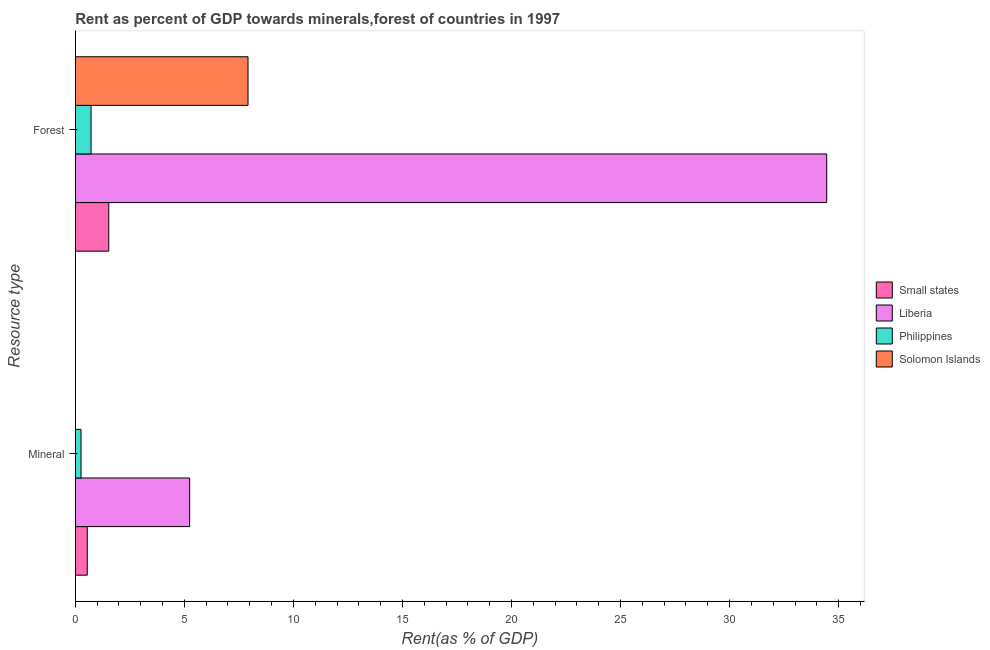How many different coloured bars are there?
Your answer should be very brief. 4. How many groups of bars are there?
Provide a succinct answer. 2. Are the number of bars on each tick of the Y-axis equal?
Provide a short and direct response. Yes. How many bars are there on the 2nd tick from the top?
Give a very brief answer. 4. How many bars are there on the 1st tick from the bottom?
Keep it short and to the point. 4. What is the label of the 2nd group of bars from the top?
Offer a terse response. Mineral. What is the forest rent in Solomon Islands?
Offer a terse response. 7.92. Across all countries, what is the maximum forest rent?
Offer a very short reply. 34.45. Across all countries, what is the minimum mineral rent?
Your answer should be very brief. 0. In which country was the mineral rent maximum?
Keep it short and to the point. Liberia. In which country was the forest rent minimum?
Provide a succinct answer. Philippines. What is the total forest rent in the graph?
Give a very brief answer. 44.63. What is the difference between the forest rent in Liberia and that in Solomon Islands?
Ensure brevity in your answer.  26.53. What is the difference between the mineral rent in Solomon Islands and the forest rent in Small states?
Offer a very short reply. -1.53. What is the average mineral rent per country?
Your answer should be compact. 1.51. What is the difference between the forest rent and mineral rent in Philippines?
Give a very brief answer. 0.46. In how many countries, is the forest rent greater than 20 %?
Give a very brief answer. 1. What is the ratio of the forest rent in Small states to that in Liberia?
Give a very brief answer. 0.04. Is the mineral rent in Small states less than that in Solomon Islands?
Your answer should be compact. No. What does the 4th bar from the top in Mineral represents?
Your answer should be compact. Small states. What does the 4th bar from the bottom in Mineral represents?
Offer a terse response. Solomon Islands. How many bars are there?
Provide a short and direct response. 8. How many countries are there in the graph?
Ensure brevity in your answer.  4. Does the graph contain grids?
Your response must be concise. No. What is the title of the graph?
Offer a terse response. Rent as percent of GDP towards minerals,forest of countries in 1997. What is the label or title of the X-axis?
Your answer should be very brief. Rent(as % of GDP). What is the label or title of the Y-axis?
Your answer should be very brief. Resource type. What is the Rent(as % of GDP) of Small states in Mineral?
Your response must be concise. 0.55. What is the Rent(as % of GDP) in Liberia in Mineral?
Offer a terse response. 5.24. What is the Rent(as % of GDP) in Philippines in Mineral?
Provide a short and direct response. 0.26. What is the Rent(as % of GDP) in Solomon Islands in Mineral?
Your answer should be compact. 0. What is the Rent(as % of GDP) of Small states in Forest?
Your response must be concise. 1.53. What is the Rent(as % of GDP) in Liberia in Forest?
Keep it short and to the point. 34.45. What is the Rent(as % of GDP) in Philippines in Forest?
Your answer should be compact. 0.72. What is the Rent(as % of GDP) in Solomon Islands in Forest?
Your response must be concise. 7.92. Across all Resource type, what is the maximum Rent(as % of GDP) in Small states?
Make the answer very short. 1.53. Across all Resource type, what is the maximum Rent(as % of GDP) of Liberia?
Keep it short and to the point. 34.45. Across all Resource type, what is the maximum Rent(as % of GDP) of Philippines?
Your response must be concise. 0.72. Across all Resource type, what is the maximum Rent(as % of GDP) in Solomon Islands?
Your answer should be compact. 7.92. Across all Resource type, what is the minimum Rent(as % of GDP) in Small states?
Your answer should be very brief. 0.55. Across all Resource type, what is the minimum Rent(as % of GDP) in Liberia?
Offer a terse response. 5.24. Across all Resource type, what is the minimum Rent(as % of GDP) of Philippines?
Provide a succinct answer. 0.26. Across all Resource type, what is the minimum Rent(as % of GDP) of Solomon Islands?
Offer a terse response. 0. What is the total Rent(as % of GDP) of Small states in the graph?
Offer a terse response. 2.08. What is the total Rent(as % of GDP) in Liberia in the graph?
Keep it short and to the point. 39.69. What is the total Rent(as % of GDP) in Philippines in the graph?
Your response must be concise. 0.98. What is the total Rent(as % of GDP) in Solomon Islands in the graph?
Your response must be concise. 7.92. What is the difference between the Rent(as % of GDP) in Small states in Mineral and that in Forest?
Your answer should be very brief. -0.98. What is the difference between the Rent(as % of GDP) of Liberia in Mineral and that in Forest?
Provide a succinct answer. -29.21. What is the difference between the Rent(as % of GDP) of Philippines in Mineral and that in Forest?
Offer a terse response. -0.46. What is the difference between the Rent(as % of GDP) of Solomon Islands in Mineral and that in Forest?
Keep it short and to the point. -7.92. What is the difference between the Rent(as % of GDP) in Small states in Mineral and the Rent(as % of GDP) in Liberia in Forest?
Offer a terse response. -33.9. What is the difference between the Rent(as % of GDP) of Small states in Mineral and the Rent(as % of GDP) of Philippines in Forest?
Offer a very short reply. -0.17. What is the difference between the Rent(as % of GDP) in Small states in Mineral and the Rent(as % of GDP) in Solomon Islands in Forest?
Give a very brief answer. -7.37. What is the difference between the Rent(as % of GDP) of Liberia in Mineral and the Rent(as % of GDP) of Philippines in Forest?
Offer a very short reply. 4.52. What is the difference between the Rent(as % of GDP) of Liberia in Mineral and the Rent(as % of GDP) of Solomon Islands in Forest?
Offer a very short reply. -2.68. What is the difference between the Rent(as % of GDP) of Philippines in Mineral and the Rent(as % of GDP) of Solomon Islands in Forest?
Offer a very short reply. -7.66. What is the average Rent(as % of GDP) in Small states per Resource type?
Your answer should be compact. 1.04. What is the average Rent(as % of GDP) of Liberia per Resource type?
Provide a succinct answer. 19.85. What is the average Rent(as % of GDP) in Philippines per Resource type?
Give a very brief answer. 0.49. What is the average Rent(as % of GDP) of Solomon Islands per Resource type?
Provide a succinct answer. 3.96. What is the difference between the Rent(as % of GDP) of Small states and Rent(as % of GDP) of Liberia in Mineral?
Ensure brevity in your answer.  -4.69. What is the difference between the Rent(as % of GDP) in Small states and Rent(as % of GDP) in Philippines in Mineral?
Ensure brevity in your answer.  0.29. What is the difference between the Rent(as % of GDP) in Small states and Rent(as % of GDP) in Solomon Islands in Mineral?
Offer a terse response. 0.55. What is the difference between the Rent(as % of GDP) of Liberia and Rent(as % of GDP) of Philippines in Mineral?
Offer a terse response. 4.98. What is the difference between the Rent(as % of GDP) of Liberia and Rent(as % of GDP) of Solomon Islands in Mineral?
Make the answer very short. 5.24. What is the difference between the Rent(as % of GDP) in Philippines and Rent(as % of GDP) in Solomon Islands in Mineral?
Offer a terse response. 0.26. What is the difference between the Rent(as % of GDP) of Small states and Rent(as % of GDP) of Liberia in Forest?
Keep it short and to the point. -32.92. What is the difference between the Rent(as % of GDP) in Small states and Rent(as % of GDP) in Philippines in Forest?
Offer a terse response. 0.81. What is the difference between the Rent(as % of GDP) in Small states and Rent(as % of GDP) in Solomon Islands in Forest?
Offer a very short reply. -6.39. What is the difference between the Rent(as % of GDP) in Liberia and Rent(as % of GDP) in Philippines in Forest?
Your answer should be very brief. 33.73. What is the difference between the Rent(as % of GDP) of Liberia and Rent(as % of GDP) of Solomon Islands in Forest?
Your answer should be very brief. 26.53. What is the difference between the Rent(as % of GDP) in Philippines and Rent(as % of GDP) in Solomon Islands in Forest?
Keep it short and to the point. -7.2. What is the ratio of the Rent(as % of GDP) in Small states in Mineral to that in Forest?
Your answer should be compact. 0.36. What is the ratio of the Rent(as % of GDP) of Liberia in Mineral to that in Forest?
Give a very brief answer. 0.15. What is the ratio of the Rent(as % of GDP) of Philippines in Mineral to that in Forest?
Your answer should be very brief. 0.36. What is the ratio of the Rent(as % of GDP) in Solomon Islands in Mineral to that in Forest?
Your answer should be compact. 0. What is the difference between the highest and the second highest Rent(as % of GDP) in Small states?
Ensure brevity in your answer.  0.98. What is the difference between the highest and the second highest Rent(as % of GDP) of Liberia?
Provide a succinct answer. 29.21. What is the difference between the highest and the second highest Rent(as % of GDP) in Philippines?
Give a very brief answer. 0.46. What is the difference between the highest and the second highest Rent(as % of GDP) of Solomon Islands?
Ensure brevity in your answer.  7.92. What is the difference between the highest and the lowest Rent(as % of GDP) in Small states?
Offer a very short reply. 0.98. What is the difference between the highest and the lowest Rent(as % of GDP) of Liberia?
Your answer should be very brief. 29.21. What is the difference between the highest and the lowest Rent(as % of GDP) in Philippines?
Provide a succinct answer. 0.46. What is the difference between the highest and the lowest Rent(as % of GDP) of Solomon Islands?
Offer a very short reply. 7.92. 